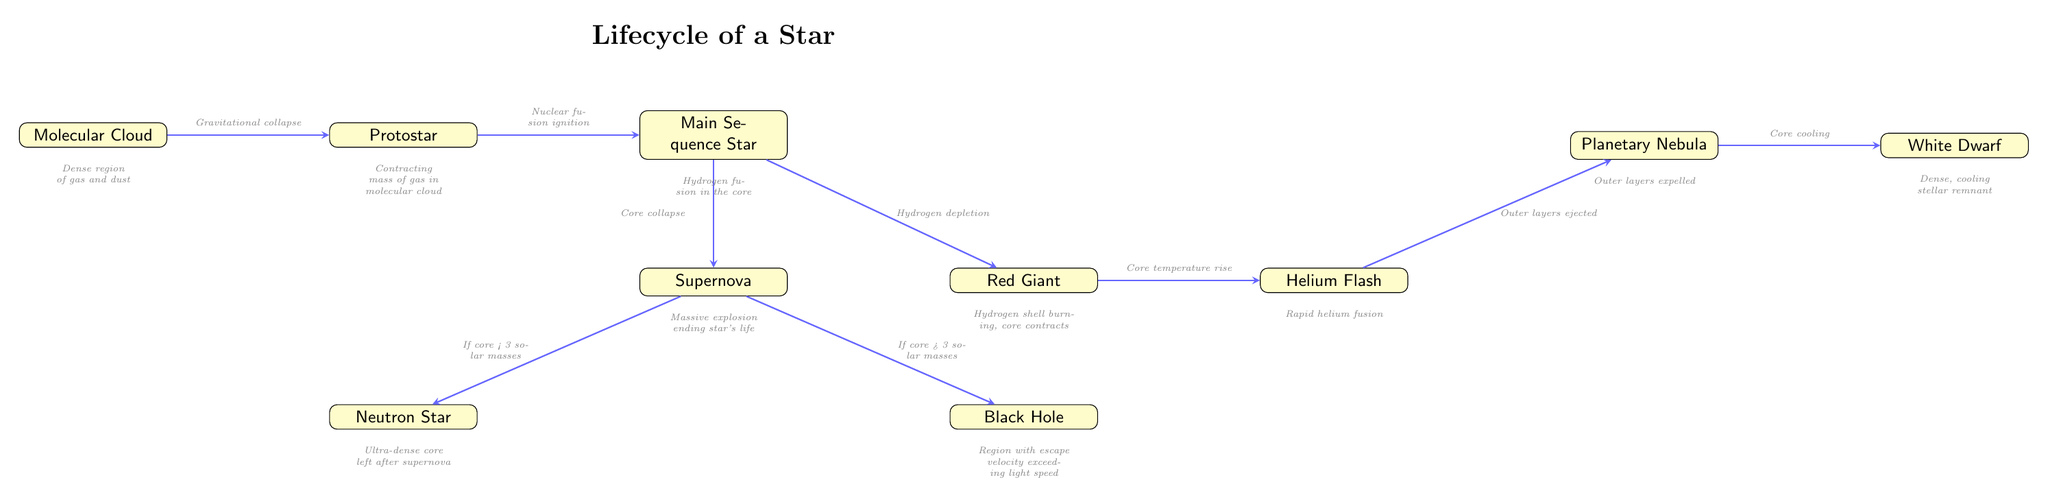What is the first stage in a star's lifecycle? The diagram shows that the first stage is the "Molecular Cloud," which is indicated as the starting point of the lifecycle.
Answer: Molecular Cloud What happens to a star after it becomes a Main Sequence Star? From the diagram, after the Main Sequence Star stage, the next stage is indicated as "Red Giant," showing the progression in the lifecycle.
Answer: Red Giant How many end states are possible after a supernova? The diagram illustrates two end states following the "Supernova" stage: "Neutron Star" and "Black Hole," clearly indicating that there are two distinct outcomes.
Answer: 2 What triggers the transition from Protostar to Main Sequence Star? The transition from "Protostar" to "Main Sequence Star" is labeled as "Nuclear fusion ignition," indicating the specific cause for this change.
Answer: Nuclear fusion ignition What is the condition for a star to become a Black Hole? According to the diagram, a star will become a "Black Hole" if its core mass exceeds 3 solar masses, showing this clear threshold for the outcome.
Answer: Core > 3 solar masses What occurs during the Helium Flash stage? The diagram states that during the "Helium Flash" stage, "Rapid helium fusion" takes place, indicating the significant event that occurs in this phase.
Answer: Rapid helium fusion What process leads to the formation of a White Dwarf? The arrow indicates that the "Planetary Nebula" stage leads to "Core cooling," and the final outcome of this phase is the formation of the "White Dwarf." Hence, core cooling is the process that leads to this residual state.
Answer: Core cooling If a star's core is less than 3 solar masses after a supernova, what will it transform into? The diagram specifies that if the core mass is less than 3 solar masses, the result will be a "Neutron Star." Thus, the transformation depends specifically on this mass condition.
Answer: Neutron Star What leads to the ejection of outer layers during the stellar lifecycle? The diagram marks that "Outer layers ejected" occurs at the "Planetary Nebula" stage, which is a result of processes leading up to this stage, such as "Helium Flash."
Answer: Outer layers ejected 